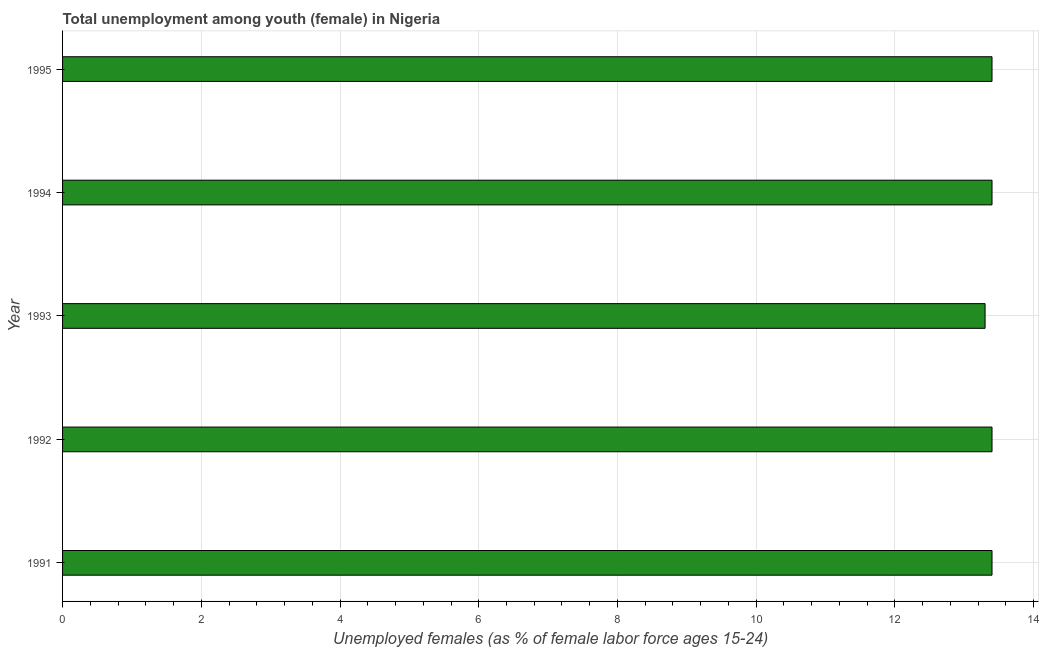What is the title of the graph?
Provide a succinct answer. Total unemployment among youth (female) in Nigeria. What is the label or title of the X-axis?
Offer a terse response. Unemployed females (as % of female labor force ages 15-24). What is the label or title of the Y-axis?
Keep it short and to the point. Year. What is the unemployed female youth population in 1992?
Give a very brief answer. 13.4. Across all years, what is the maximum unemployed female youth population?
Your response must be concise. 13.4. Across all years, what is the minimum unemployed female youth population?
Provide a short and direct response. 13.3. What is the sum of the unemployed female youth population?
Offer a very short reply. 66.9. What is the difference between the unemployed female youth population in 1993 and 1994?
Give a very brief answer. -0.1. What is the average unemployed female youth population per year?
Give a very brief answer. 13.38. What is the median unemployed female youth population?
Your answer should be very brief. 13.4. Do a majority of the years between 1992 and 1994 (inclusive) have unemployed female youth population greater than 10 %?
Make the answer very short. Yes. What is the ratio of the unemployed female youth population in 1991 to that in 1994?
Keep it short and to the point. 1. Is the unemployed female youth population in 1991 less than that in 1995?
Keep it short and to the point. No. What is the difference between the highest and the lowest unemployed female youth population?
Your answer should be compact. 0.1. How many bars are there?
Ensure brevity in your answer.  5. How many years are there in the graph?
Your response must be concise. 5. What is the difference between two consecutive major ticks on the X-axis?
Offer a very short reply. 2. Are the values on the major ticks of X-axis written in scientific E-notation?
Offer a terse response. No. What is the Unemployed females (as % of female labor force ages 15-24) of 1991?
Offer a very short reply. 13.4. What is the Unemployed females (as % of female labor force ages 15-24) of 1992?
Your answer should be very brief. 13.4. What is the Unemployed females (as % of female labor force ages 15-24) in 1993?
Give a very brief answer. 13.3. What is the Unemployed females (as % of female labor force ages 15-24) in 1994?
Your answer should be very brief. 13.4. What is the Unemployed females (as % of female labor force ages 15-24) in 1995?
Ensure brevity in your answer.  13.4. What is the difference between the Unemployed females (as % of female labor force ages 15-24) in 1991 and 1992?
Provide a succinct answer. 0. What is the difference between the Unemployed females (as % of female labor force ages 15-24) in 1991 and 1995?
Offer a terse response. 0. What is the difference between the Unemployed females (as % of female labor force ages 15-24) in 1992 and 1993?
Provide a succinct answer. 0.1. What is the difference between the Unemployed females (as % of female labor force ages 15-24) in 1992 and 1995?
Make the answer very short. 0. What is the difference between the Unemployed females (as % of female labor force ages 15-24) in 1993 and 1994?
Make the answer very short. -0.1. What is the difference between the Unemployed females (as % of female labor force ages 15-24) in 1993 and 1995?
Your answer should be very brief. -0.1. What is the ratio of the Unemployed females (as % of female labor force ages 15-24) in 1991 to that in 1993?
Keep it short and to the point. 1.01. What is the ratio of the Unemployed females (as % of female labor force ages 15-24) in 1991 to that in 1994?
Give a very brief answer. 1. What is the ratio of the Unemployed females (as % of female labor force ages 15-24) in 1992 to that in 1993?
Your answer should be compact. 1.01. What is the ratio of the Unemployed females (as % of female labor force ages 15-24) in 1992 to that in 1994?
Offer a very short reply. 1. What is the ratio of the Unemployed females (as % of female labor force ages 15-24) in 1993 to that in 1994?
Keep it short and to the point. 0.99. What is the ratio of the Unemployed females (as % of female labor force ages 15-24) in 1994 to that in 1995?
Offer a very short reply. 1. 